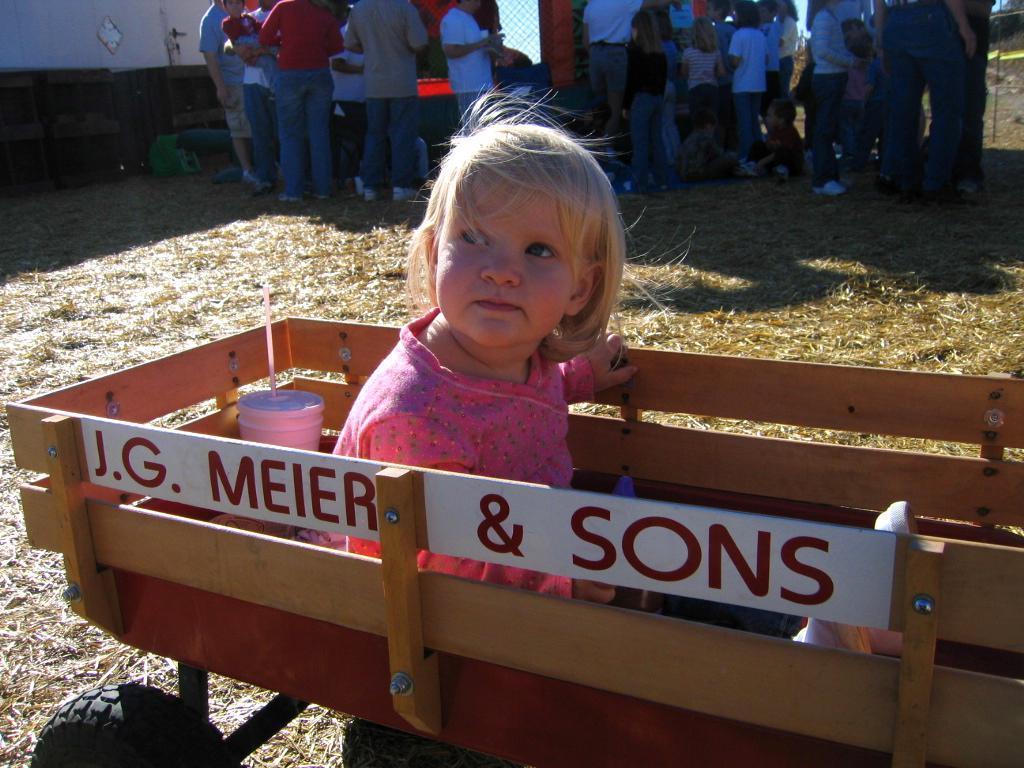Can you describe this image briefly? Here we can see a kid on the cart. In the background we can see group of people and wall. 